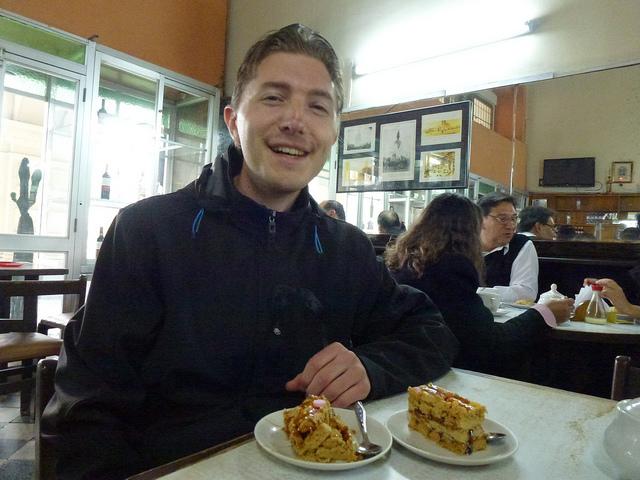Is there a mirror behind him?
Short answer required. No. How many plates in front of the man?
Be succinct. 2. What room in the house would this be?
Quick response, please. Kitchen. Does the man like his meal?
Write a very short answer. Yes. 